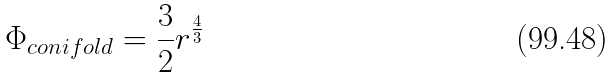<formula> <loc_0><loc_0><loc_500><loc_500>\Phi _ { c o n i f o l d } = \frac { 3 } { 2 } r ^ { \frac { 4 } { 3 } }</formula> 